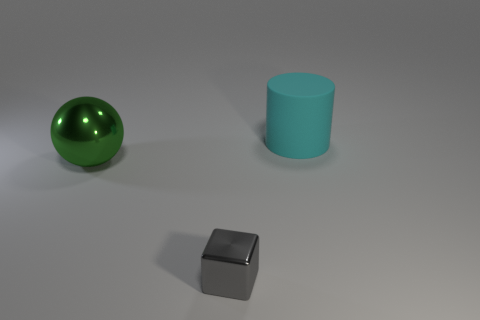Are there any other things that have the same size as the cube?
Keep it short and to the point. No. There is a large object that is on the left side of the rubber cylinder behind the big object that is on the left side of the cyan cylinder; what is its color?
Keep it short and to the point. Green. Is the ball the same size as the cyan object?
Your answer should be very brief. Yes. How many green balls have the same size as the cyan object?
Your response must be concise. 1. Does the large object that is to the left of the metal block have the same material as the object in front of the large green shiny sphere?
Offer a very short reply. Yes. Is there anything else that has the same shape as the tiny object?
Provide a short and direct response. No. What is the color of the cube?
Provide a succinct answer. Gray. What number of other big metal things are the same shape as the big cyan object?
Provide a short and direct response. 0. What color is the object that is the same size as the cylinder?
Your answer should be very brief. Green. Is there a cyan rubber cylinder?
Your response must be concise. Yes. 